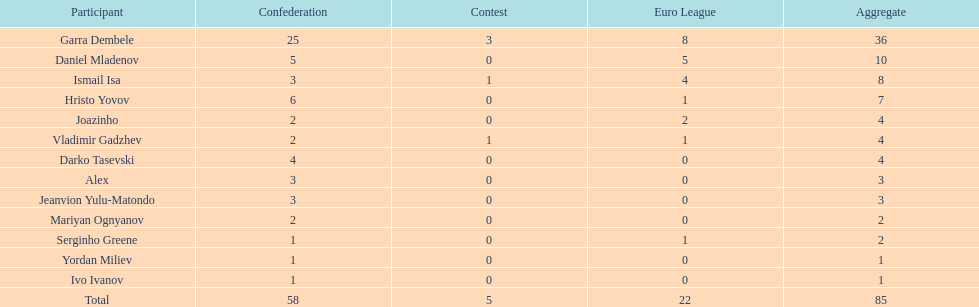Which is the only player from germany? Jeanvion Yulu-Matondo. 